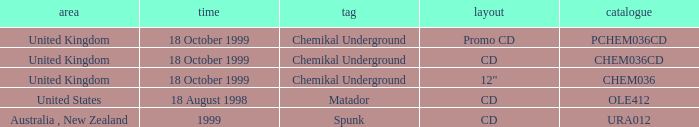What date is associated with the Spunk label? 1999.0. 